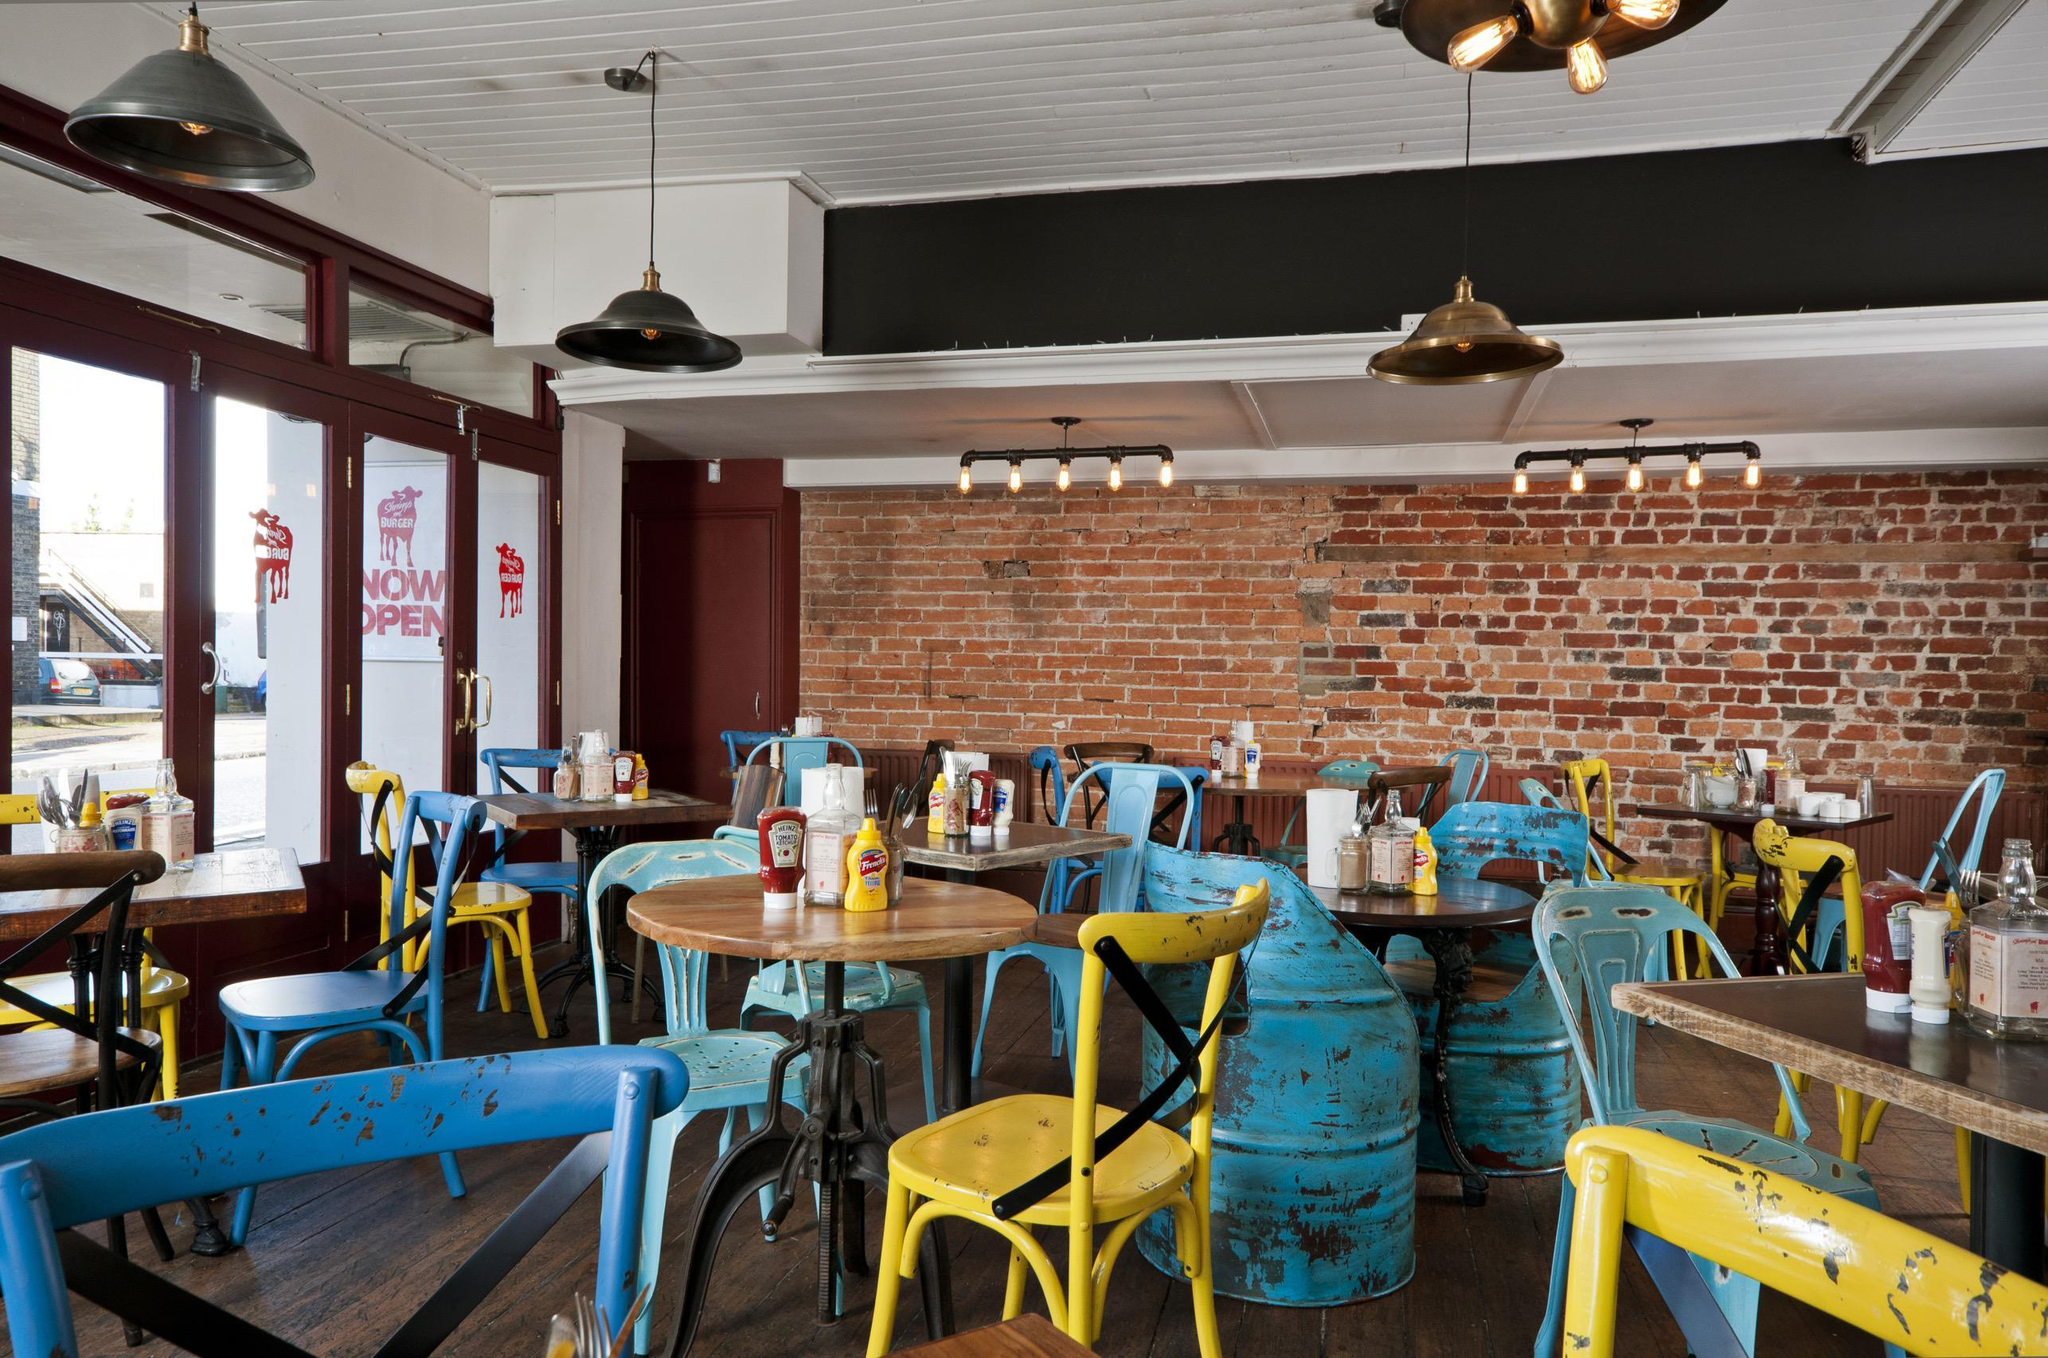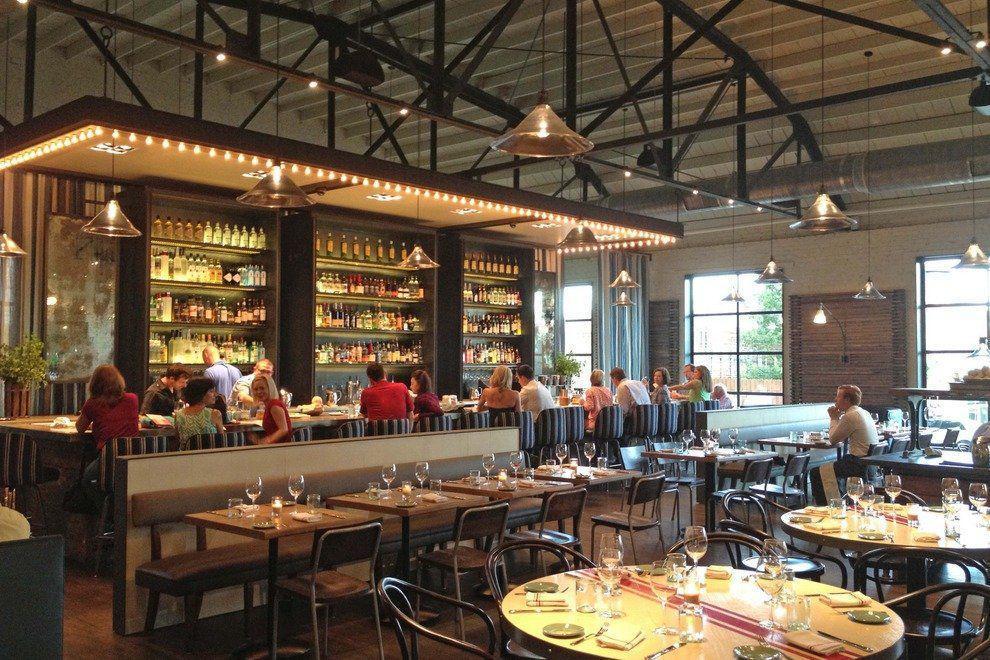The first image is the image on the left, the second image is the image on the right. Analyze the images presented: Is the assertion "There are two restaurants will all of its seats empty." valid? Answer yes or no. No. The first image is the image on the left, the second image is the image on the right. Considering the images on both sides, is "There are people in the right image but not in the left image." valid? Answer yes or no. Yes. 